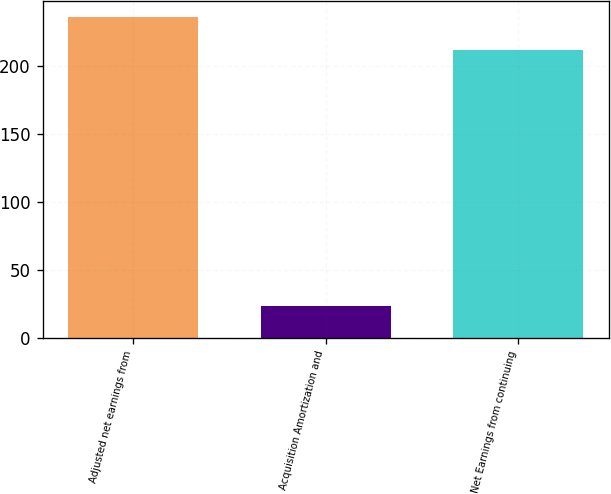<chart> <loc_0><loc_0><loc_500><loc_500><bar_chart><fcel>Adjusted net earnings from<fcel>Acquisition Amortization and<fcel>Net Earnings from continuing<nl><fcel>236<fcel>23.8<fcel>212.1<nl></chart> 